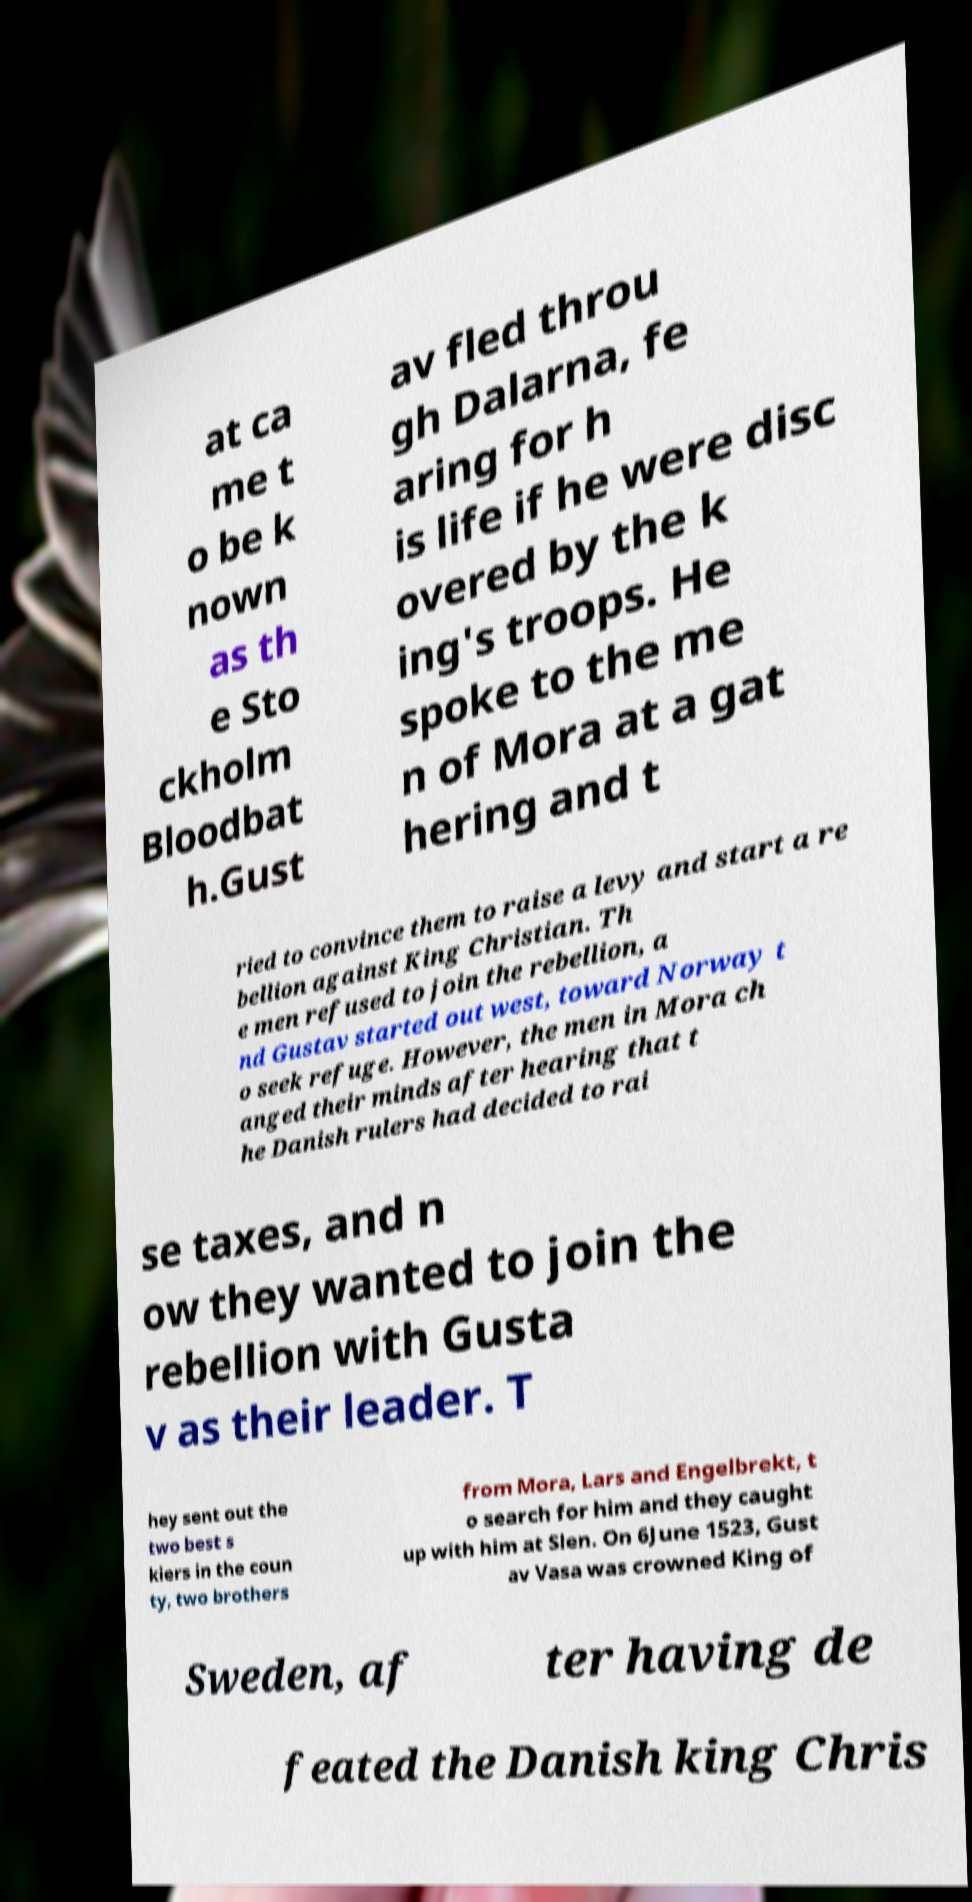Please read and relay the text visible in this image. What does it say? at ca me t o be k nown as th e Sto ckholm Bloodbat h.Gust av fled throu gh Dalarna, fe aring for h is life if he were disc overed by the k ing's troops. He spoke to the me n of Mora at a gat hering and t ried to convince them to raise a levy and start a re bellion against King Christian. Th e men refused to join the rebellion, a nd Gustav started out west, toward Norway t o seek refuge. However, the men in Mora ch anged their minds after hearing that t he Danish rulers had decided to rai se taxes, and n ow they wanted to join the rebellion with Gusta v as their leader. T hey sent out the two best s kiers in the coun ty, two brothers from Mora, Lars and Engelbrekt, t o search for him and they caught up with him at Slen. On 6June 1523, Gust av Vasa was crowned King of Sweden, af ter having de feated the Danish king Chris 